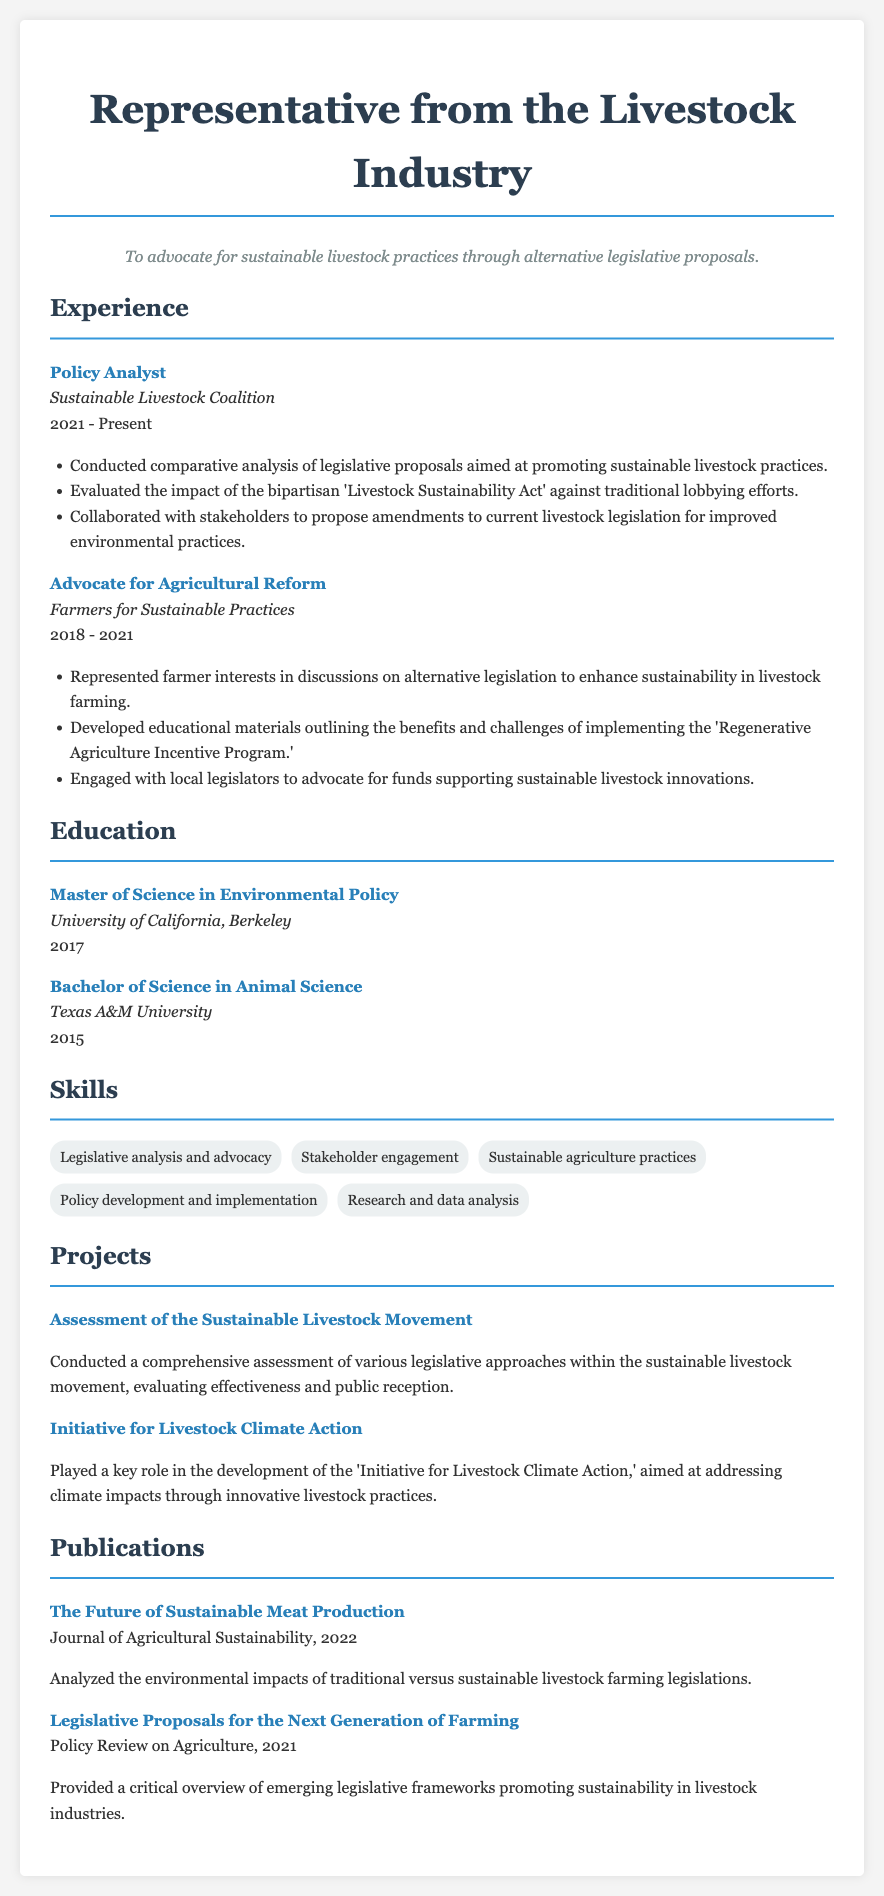What is the highest degree listed? The highest degree is the highest level of education mentioned in the resume, which is a Master of Science in Environmental Policy.
Answer: Master of Science in Environmental Policy What organization is mentioned in the current position? The organization currently being worked for is described in the experience section under the current job title, which is Sustainable Livestock Coalition.
Answer: Sustainable Livestock Coalition In which year was the Bachelor's degree completed? The document lists the year of completion for the Bachelor's degree under the education section, which is 2015.
Answer: 2015 What was the focus of the publication titled "The Future of Sustainable Meat Production"? The focus of the publication can be found within its description, emphasizing the environmental impacts of traditional versus sustainable livestock farming legislations.
Answer: Environmental impacts How many years of experience are indicated in the Policy Analyst position? The experience in the Policy Analyst position shows the duration from 2021 to the present year, which totals approximately 2 years.
Answer: 2 years What was one of the main responsibilities in the role of Advocate for Agricultural Reform? The main responsibilities are outlined in the experience section, where it states that representing farmer interests in discussions was a key duty.
Answer: Represented farmer interests What type of analysis was performed in the job title "Policy Analyst"? The analysis type is mentioned in the responsibilities, clarifying that it involved a comparative analysis of legislative proposals.
Answer: Comparative analysis What initiative is linked to climate action in the projects section? The document clearly names the initiative focused on climate action in livestock practices as the 'Initiative for Livestock Climate Action.'
Answer: Initiative for Livestock Climate Action How many publications are mentioned in the resume? The resume lists the number of publication items in the publications section, specifically mentioning two.
Answer: Two 